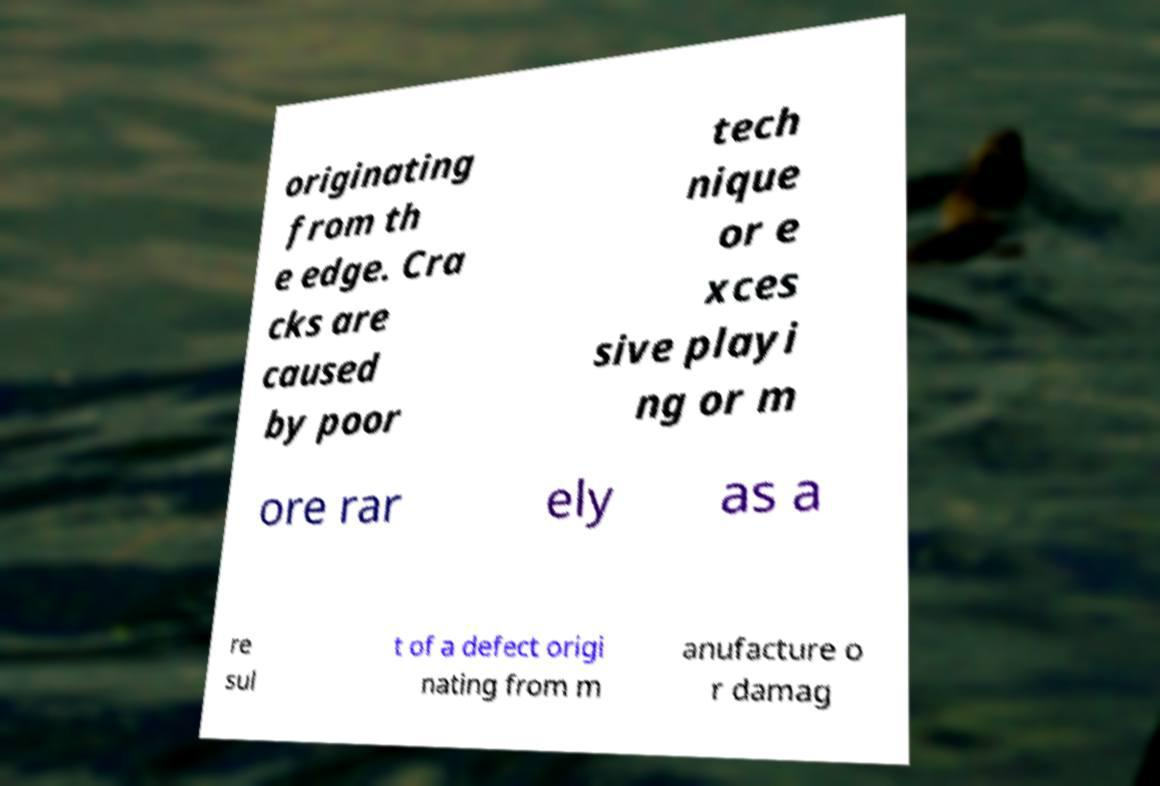Please identify and transcribe the text found in this image. originating from th e edge. Cra cks are caused by poor tech nique or e xces sive playi ng or m ore rar ely as a re sul t of a defect origi nating from m anufacture o r damag 